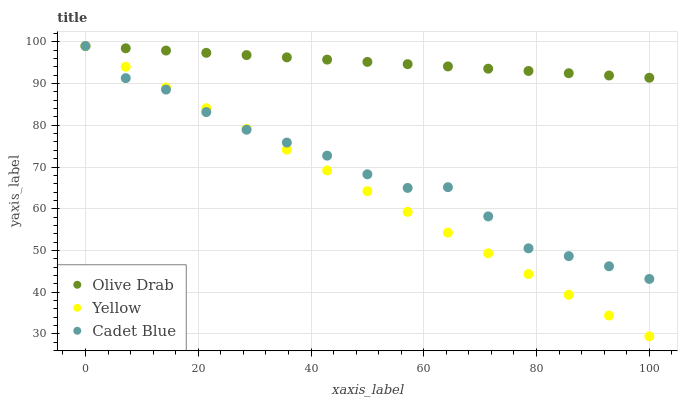Does Yellow have the minimum area under the curve?
Answer yes or no. Yes. Does Olive Drab have the maximum area under the curve?
Answer yes or no. Yes. Does Olive Drab have the minimum area under the curve?
Answer yes or no. No. Does Yellow have the maximum area under the curve?
Answer yes or no. No. Is Yellow the smoothest?
Answer yes or no. Yes. Is Cadet Blue the roughest?
Answer yes or no. Yes. Is Olive Drab the smoothest?
Answer yes or no. No. Is Olive Drab the roughest?
Answer yes or no. No. Does Yellow have the lowest value?
Answer yes or no. Yes. Does Olive Drab have the lowest value?
Answer yes or no. No. Does Olive Drab have the highest value?
Answer yes or no. Yes. Does Yellow intersect Olive Drab?
Answer yes or no. Yes. Is Yellow less than Olive Drab?
Answer yes or no. No. Is Yellow greater than Olive Drab?
Answer yes or no. No. 